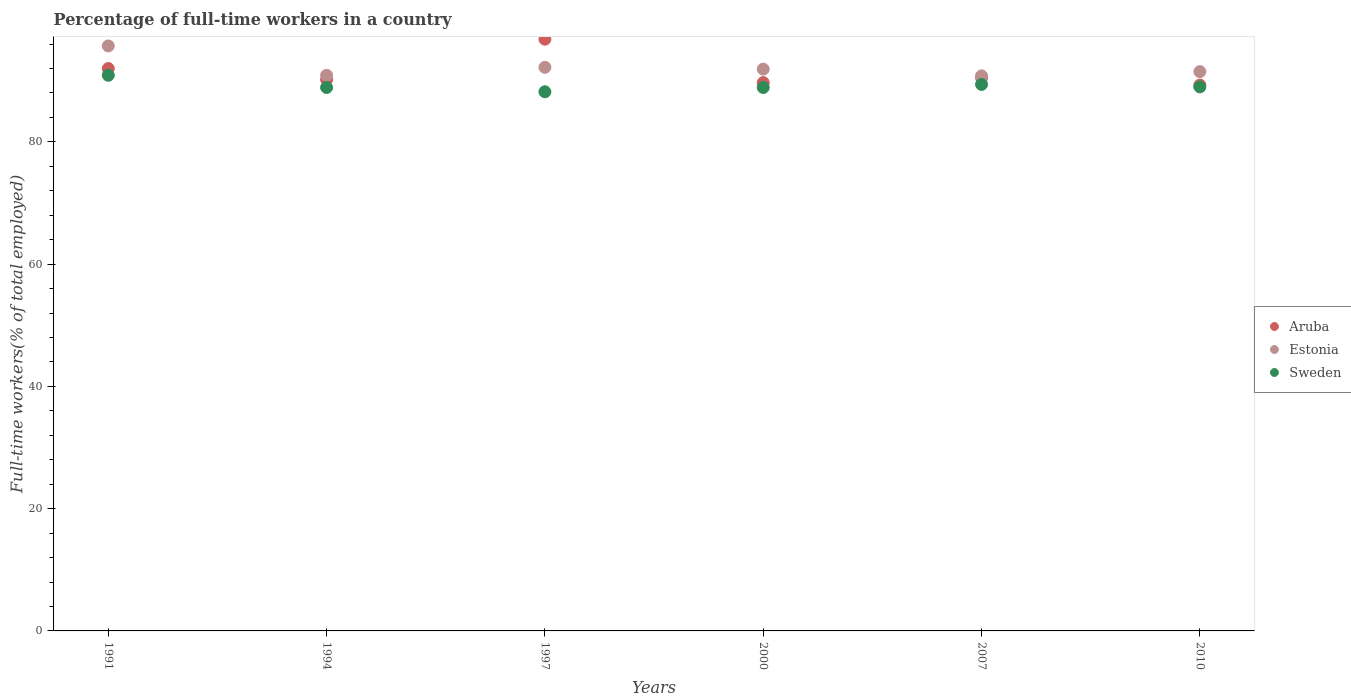What is the percentage of full-time workers in Sweden in 1994?
Your answer should be very brief. 88.9. Across all years, what is the maximum percentage of full-time workers in Aruba?
Your answer should be very brief. 96.8. Across all years, what is the minimum percentage of full-time workers in Sweden?
Offer a very short reply. 88.2. In which year was the percentage of full-time workers in Aruba maximum?
Provide a succinct answer. 1997. In which year was the percentage of full-time workers in Aruba minimum?
Offer a terse response. 2010. What is the total percentage of full-time workers in Estonia in the graph?
Your answer should be very brief. 553. What is the difference between the percentage of full-time workers in Aruba in 2000 and that in 2007?
Your answer should be compact. -0.8. What is the difference between the percentage of full-time workers in Estonia in 1991 and the percentage of full-time workers in Aruba in 1994?
Ensure brevity in your answer.  5.5. What is the average percentage of full-time workers in Estonia per year?
Offer a very short reply. 92.17. In the year 2007, what is the difference between the percentage of full-time workers in Estonia and percentage of full-time workers in Sweden?
Give a very brief answer. 1.4. What is the ratio of the percentage of full-time workers in Aruba in 2000 to that in 2010?
Provide a short and direct response. 1. Is the difference between the percentage of full-time workers in Estonia in 1991 and 2010 greater than the difference between the percentage of full-time workers in Sweden in 1991 and 2010?
Give a very brief answer. Yes. What is the difference between the highest and the second highest percentage of full-time workers in Estonia?
Keep it short and to the point. 3.5. What is the difference between the highest and the lowest percentage of full-time workers in Estonia?
Keep it short and to the point. 4.9. In how many years, is the percentage of full-time workers in Estonia greater than the average percentage of full-time workers in Estonia taken over all years?
Provide a short and direct response. 2. Is it the case that in every year, the sum of the percentage of full-time workers in Sweden and percentage of full-time workers in Estonia  is greater than the percentage of full-time workers in Aruba?
Provide a succinct answer. Yes. Is the percentage of full-time workers in Sweden strictly less than the percentage of full-time workers in Aruba over the years?
Offer a very short reply. Yes. How many years are there in the graph?
Ensure brevity in your answer.  6. Are the values on the major ticks of Y-axis written in scientific E-notation?
Your answer should be very brief. No. Does the graph contain grids?
Your answer should be very brief. No. Where does the legend appear in the graph?
Make the answer very short. Center right. How many legend labels are there?
Make the answer very short. 3. How are the legend labels stacked?
Keep it short and to the point. Vertical. What is the title of the graph?
Provide a succinct answer. Percentage of full-time workers in a country. What is the label or title of the Y-axis?
Keep it short and to the point. Full-time workers(% of total employed). What is the Full-time workers(% of total employed) in Aruba in 1991?
Provide a succinct answer. 92. What is the Full-time workers(% of total employed) in Estonia in 1991?
Provide a succinct answer. 95.7. What is the Full-time workers(% of total employed) in Sweden in 1991?
Your answer should be compact. 90.9. What is the Full-time workers(% of total employed) of Aruba in 1994?
Keep it short and to the point. 90.2. What is the Full-time workers(% of total employed) of Estonia in 1994?
Ensure brevity in your answer.  90.9. What is the Full-time workers(% of total employed) of Sweden in 1994?
Your answer should be very brief. 88.9. What is the Full-time workers(% of total employed) in Aruba in 1997?
Your response must be concise. 96.8. What is the Full-time workers(% of total employed) in Estonia in 1997?
Give a very brief answer. 92.2. What is the Full-time workers(% of total employed) in Sweden in 1997?
Provide a short and direct response. 88.2. What is the Full-time workers(% of total employed) in Aruba in 2000?
Provide a succinct answer. 89.7. What is the Full-time workers(% of total employed) in Estonia in 2000?
Ensure brevity in your answer.  91.9. What is the Full-time workers(% of total employed) of Sweden in 2000?
Keep it short and to the point. 88.9. What is the Full-time workers(% of total employed) in Aruba in 2007?
Your answer should be compact. 90.5. What is the Full-time workers(% of total employed) of Estonia in 2007?
Your response must be concise. 90.8. What is the Full-time workers(% of total employed) of Sweden in 2007?
Provide a short and direct response. 89.4. What is the Full-time workers(% of total employed) of Aruba in 2010?
Provide a short and direct response. 89.3. What is the Full-time workers(% of total employed) in Estonia in 2010?
Your answer should be very brief. 91.5. What is the Full-time workers(% of total employed) in Sweden in 2010?
Provide a short and direct response. 89. Across all years, what is the maximum Full-time workers(% of total employed) of Aruba?
Ensure brevity in your answer.  96.8. Across all years, what is the maximum Full-time workers(% of total employed) in Estonia?
Ensure brevity in your answer.  95.7. Across all years, what is the maximum Full-time workers(% of total employed) in Sweden?
Give a very brief answer. 90.9. Across all years, what is the minimum Full-time workers(% of total employed) in Aruba?
Provide a short and direct response. 89.3. Across all years, what is the minimum Full-time workers(% of total employed) of Estonia?
Offer a very short reply. 90.8. Across all years, what is the minimum Full-time workers(% of total employed) of Sweden?
Your answer should be compact. 88.2. What is the total Full-time workers(% of total employed) in Aruba in the graph?
Make the answer very short. 548.5. What is the total Full-time workers(% of total employed) in Estonia in the graph?
Make the answer very short. 553. What is the total Full-time workers(% of total employed) of Sweden in the graph?
Keep it short and to the point. 535.3. What is the difference between the Full-time workers(% of total employed) in Aruba in 1991 and that in 1994?
Make the answer very short. 1.8. What is the difference between the Full-time workers(% of total employed) in Estonia in 1991 and that in 1994?
Provide a succinct answer. 4.8. What is the difference between the Full-time workers(% of total employed) in Sweden in 1991 and that in 1994?
Make the answer very short. 2. What is the difference between the Full-time workers(% of total employed) of Estonia in 1991 and that in 1997?
Ensure brevity in your answer.  3.5. What is the difference between the Full-time workers(% of total employed) in Sweden in 1991 and that in 1997?
Make the answer very short. 2.7. What is the difference between the Full-time workers(% of total employed) in Estonia in 1991 and that in 2000?
Your answer should be compact. 3.8. What is the difference between the Full-time workers(% of total employed) of Aruba in 1991 and that in 2007?
Provide a short and direct response. 1.5. What is the difference between the Full-time workers(% of total employed) of Estonia in 1991 and that in 2007?
Provide a succinct answer. 4.9. What is the difference between the Full-time workers(% of total employed) of Sweden in 1991 and that in 2007?
Your answer should be very brief. 1.5. What is the difference between the Full-time workers(% of total employed) of Aruba in 1994 and that in 1997?
Keep it short and to the point. -6.6. What is the difference between the Full-time workers(% of total employed) of Estonia in 1994 and that in 1997?
Your answer should be very brief. -1.3. What is the difference between the Full-time workers(% of total employed) in Estonia in 1994 and that in 2007?
Offer a very short reply. 0.1. What is the difference between the Full-time workers(% of total employed) of Aruba in 1994 and that in 2010?
Offer a terse response. 0.9. What is the difference between the Full-time workers(% of total employed) of Estonia in 1994 and that in 2010?
Keep it short and to the point. -0.6. What is the difference between the Full-time workers(% of total employed) of Sweden in 1994 and that in 2010?
Your response must be concise. -0.1. What is the difference between the Full-time workers(% of total employed) of Sweden in 1997 and that in 2000?
Your answer should be very brief. -0.7. What is the difference between the Full-time workers(% of total employed) in Sweden in 1997 and that in 2007?
Keep it short and to the point. -1.2. What is the difference between the Full-time workers(% of total employed) in Aruba in 1997 and that in 2010?
Offer a terse response. 7.5. What is the difference between the Full-time workers(% of total employed) of Aruba in 2000 and that in 2007?
Provide a succinct answer. -0.8. What is the difference between the Full-time workers(% of total employed) in Estonia in 2000 and that in 2007?
Give a very brief answer. 1.1. What is the difference between the Full-time workers(% of total employed) of Sweden in 2000 and that in 2007?
Your answer should be very brief. -0.5. What is the difference between the Full-time workers(% of total employed) of Aruba in 2000 and that in 2010?
Offer a very short reply. 0.4. What is the difference between the Full-time workers(% of total employed) of Sweden in 2000 and that in 2010?
Make the answer very short. -0.1. What is the difference between the Full-time workers(% of total employed) of Aruba in 2007 and that in 2010?
Make the answer very short. 1.2. What is the difference between the Full-time workers(% of total employed) in Aruba in 1991 and the Full-time workers(% of total employed) in Sweden in 1994?
Make the answer very short. 3.1. What is the difference between the Full-time workers(% of total employed) in Estonia in 1991 and the Full-time workers(% of total employed) in Sweden in 1994?
Give a very brief answer. 6.8. What is the difference between the Full-time workers(% of total employed) of Aruba in 1991 and the Full-time workers(% of total employed) of Estonia in 1997?
Keep it short and to the point. -0.2. What is the difference between the Full-time workers(% of total employed) in Estonia in 1991 and the Full-time workers(% of total employed) in Sweden in 1997?
Your response must be concise. 7.5. What is the difference between the Full-time workers(% of total employed) in Aruba in 1991 and the Full-time workers(% of total employed) in Estonia in 2000?
Offer a very short reply. 0.1. What is the difference between the Full-time workers(% of total employed) of Aruba in 1991 and the Full-time workers(% of total employed) of Estonia in 2007?
Your answer should be very brief. 1.2. What is the difference between the Full-time workers(% of total employed) in Aruba in 1991 and the Full-time workers(% of total employed) in Estonia in 2010?
Offer a very short reply. 0.5. What is the difference between the Full-time workers(% of total employed) of Estonia in 1991 and the Full-time workers(% of total employed) of Sweden in 2010?
Offer a terse response. 6.7. What is the difference between the Full-time workers(% of total employed) of Aruba in 1994 and the Full-time workers(% of total employed) of Sweden in 2000?
Provide a short and direct response. 1.3. What is the difference between the Full-time workers(% of total employed) of Estonia in 1994 and the Full-time workers(% of total employed) of Sweden in 2000?
Your answer should be very brief. 2. What is the difference between the Full-time workers(% of total employed) in Aruba in 1994 and the Full-time workers(% of total employed) in Estonia in 2007?
Provide a short and direct response. -0.6. What is the difference between the Full-time workers(% of total employed) of Aruba in 1994 and the Full-time workers(% of total employed) of Sweden in 2007?
Your answer should be compact. 0.8. What is the difference between the Full-time workers(% of total employed) in Estonia in 1994 and the Full-time workers(% of total employed) in Sweden in 2007?
Provide a succinct answer. 1.5. What is the difference between the Full-time workers(% of total employed) in Estonia in 1994 and the Full-time workers(% of total employed) in Sweden in 2010?
Your answer should be very brief. 1.9. What is the difference between the Full-time workers(% of total employed) of Aruba in 1997 and the Full-time workers(% of total employed) of Estonia in 2000?
Offer a very short reply. 4.9. What is the difference between the Full-time workers(% of total employed) in Estonia in 1997 and the Full-time workers(% of total employed) in Sweden in 2000?
Keep it short and to the point. 3.3. What is the difference between the Full-time workers(% of total employed) in Estonia in 1997 and the Full-time workers(% of total employed) in Sweden in 2007?
Offer a very short reply. 2.8. What is the difference between the Full-time workers(% of total employed) of Aruba in 1997 and the Full-time workers(% of total employed) of Sweden in 2010?
Make the answer very short. 7.8. What is the difference between the Full-time workers(% of total employed) of Estonia in 1997 and the Full-time workers(% of total employed) of Sweden in 2010?
Ensure brevity in your answer.  3.2. What is the difference between the Full-time workers(% of total employed) in Estonia in 2000 and the Full-time workers(% of total employed) in Sweden in 2007?
Your answer should be compact. 2.5. What is the difference between the Full-time workers(% of total employed) in Aruba in 2000 and the Full-time workers(% of total employed) in Estonia in 2010?
Your answer should be very brief. -1.8. What is the average Full-time workers(% of total employed) of Aruba per year?
Offer a terse response. 91.42. What is the average Full-time workers(% of total employed) of Estonia per year?
Give a very brief answer. 92.17. What is the average Full-time workers(% of total employed) of Sweden per year?
Your answer should be very brief. 89.22. In the year 1991, what is the difference between the Full-time workers(% of total employed) in Aruba and Full-time workers(% of total employed) in Estonia?
Offer a terse response. -3.7. In the year 1991, what is the difference between the Full-time workers(% of total employed) of Estonia and Full-time workers(% of total employed) of Sweden?
Your answer should be compact. 4.8. In the year 1994, what is the difference between the Full-time workers(% of total employed) in Estonia and Full-time workers(% of total employed) in Sweden?
Offer a very short reply. 2. In the year 1997, what is the difference between the Full-time workers(% of total employed) in Aruba and Full-time workers(% of total employed) in Sweden?
Your answer should be very brief. 8.6. In the year 1997, what is the difference between the Full-time workers(% of total employed) in Estonia and Full-time workers(% of total employed) in Sweden?
Offer a very short reply. 4. In the year 2000, what is the difference between the Full-time workers(% of total employed) of Aruba and Full-time workers(% of total employed) of Estonia?
Offer a terse response. -2.2. In the year 2000, what is the difference between the Full-time workers(% of total employed) of Estonia and Full-time workers(% of total employed) of Sweden?
Make the answer very short. 3. In the year 2007, what is the difference between the Full-time workers(% of total employed) in Aruba and Full-time workers(% of total employed) in Sweden?
Give a very brief answer. 1.1. In the year 2010, what is the difference between the Full-time workers(% of total employed) in Aruba and Full-time workers(% of total employed) in Estonia?
Keep it short and to the point. -2.2. In the year 2010, what is the difference between the Full-time workers(% of total employed) of Estonia and Full-time workers(% of total employed) of Sweden?
Provide a succinct answer. 2.5. What is the ratio of the Full-time workers(% of total employed) in Aruba in 1991 to that in 1994?
Keep it short and to the point. 1.02. What is the ratio of the Full-time workers(% of total employed) in Estonia in 1991 to that in 1994?
Make the answer very short. 1.05. What is the ratio of the Full-time workers(% of total employed) in Sweden in 1991 to that in 1994?
Ensure brevity in your answer.  1.02. What is the ratio of the Full-time workers(% of total employed) of Aruba in 1991 to that in 1997?
Make the answer very short. 0.95. What is the ratio of the Full-time workers(% of total employed) of Estonia in 1991 to that in 1997?
Provide a succinct answer. 1.04. What is the ratio of the Full-time workers(% of total employed) in Sweden in 1991 to that in 1997?
Keep it short and to the point. 1.03. What is the ratio of the Full-time workers(% of total employed) of Aruba in 1991 to that in 2000?
Make the answer very short. 1.03. What is the ratio of the Full-time workers(% of total employed) of Estonia in 1991 to that in 2000?
Offer a very short reply. 1.04. What is the ratio of the Full-time workers(% of total employed) in Sweden in 1991 to that in 2000?
Give a very brief answer. 1.02. What is the ratio of the Full-time workers(% of total employed) in Aruba in 1991 to that in 2007?
Offer a very short reply. 1.02. What is the ratio of the Full-time workers(% of total employed) of Estonia in 1991 to that in 2007?
Provide a succinct answer. 1.05. What is the ratio of the Full-time workers(% of total employed) of Sweden in 1991 to that in 2007?
Your answer should be very brief. 1.02. What is the ratio of the Full-time workers(% of total employed) in Aruba in 1991 to that in 2010?
Provide a short and direct response. 1.03. What is the ratio of the Full-time workers(% of total employed) in Estonia in 1991 to that in 2010?
Keep it short and to the point. 1.05. What is the ratio of the Full-time workers(% of total employed) in Sweden in 1991 to that in 2010?
Provide a succinct answer. 1.02. What is the ratio of the Full-time workers(% of total employed) in Aruba in 1994 to that in 1997?
Provide a short and direct response. 0.93. What is the ratio of the Full-time workers(% of total employed) of Estonia in 1994 to that in 1997?
Give a very brief answer. 0.99. What is the ratio of the Full-time workers(% of total employed) in Sweden in 1994 to that in 1997?
Provide a succinct answer. 1.01. What is the ratio of the Full-time workers(% of total employed) in Aruba in 1994 to that in 2000?
Provide a succinct answer. 1.01. What is the ratio of the Full-time workers(% of total employed) of Estonia in 1994 to that in 2000?
Ensure brevity in your answer.  0.99. What is the ratio of the Full-time workers(% of total employed) of Sweden in 1994 to that in 2007?
Your response must be concise. 0.99. What is the ratio of the Full-time workers(% of total employed) in Aruba in 1994 to that in 2010?
Make the answer very short. 1.01. What is the ratio of the Full-time workers(% of total employed) in Estonia in 1994 to that in 2010?
Your response must be concise. 0.99. What is the ratio of the Full-time workers(% of total employed) of Sweden in 1994 to that in 2010?
Your response must be concise. 1. What is the ratio of the Full-time workers(% of total employed) of Aruba in 1997 to that in 2000?
Offer a very short reply. 1.08. What is the ratio of the Full-time workers(% of total employed) of Estonia in 1997 to that in 2000?
Make the answer very short. 1. What is the ratio of the Full-time workers(% of total employed) of Sweden in 1997 to that in 2000?
Give a very brief answer. 0.99. What is the ratio of the Full-time workers(% of total employed) of Aruba in 1997 to that in 2007?
Give a very brief answer. 1.07. What is the ratio of the Full-time workers(% of total employed) in Estonia in 1997 to that in 2007?
Provide a succinct answer. 1.02. What is the ratio of the Full-time workers(% of total employed) of Sweden in 1997 to that in 2007?
Make the answer very short. 0.99. What is the ratio of the Full-time workers(% of total employed) of Aruba in 1997 to that in 2010?
Your answer should be compact. 1.08. What is the ratio of the Full-time workers(% of total employed) in Estonia in 1997 to that in 2010?
Give a very brief answer. 1.01. What is the ratio of the Full-time workers(% of total employed) of Sweden in 1997 to that in 2010?
Your answer should be very brief. 0.99. What is the ratio of the Full-time workers(% of total employed) in Estonia in 2000 to that in 2007?
Provide a short and direct response. 1.01. What is the ratio of the Full-time workers(% of total employed) of Aruba in 2007 to that in 2010?
Give a very brief answer. 1.01. What is the ratio of the Full-time workers(% of total employed) in Sweden in 2007 to that in 2010?
Keep it short and to the point. 1. What is the difference between the highest and the second highest Full-time workers(% of total employed) in Sweden?
Give a very brief answer. 1.5. What is the difference between the highest and the lowest Full-time workers(% of total employed) in Estonia?
Offer a very short reply. 4.9. What is the difference between the highest and the lowest Full-time workers(% of total employed) in Sweden?
Give a very brief answer. 2.7. 